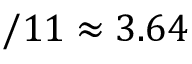<formula> <loc_0><loc_0><loc_500><loc_500>/ 1 1 \approx 3 . 6 4</formula> 